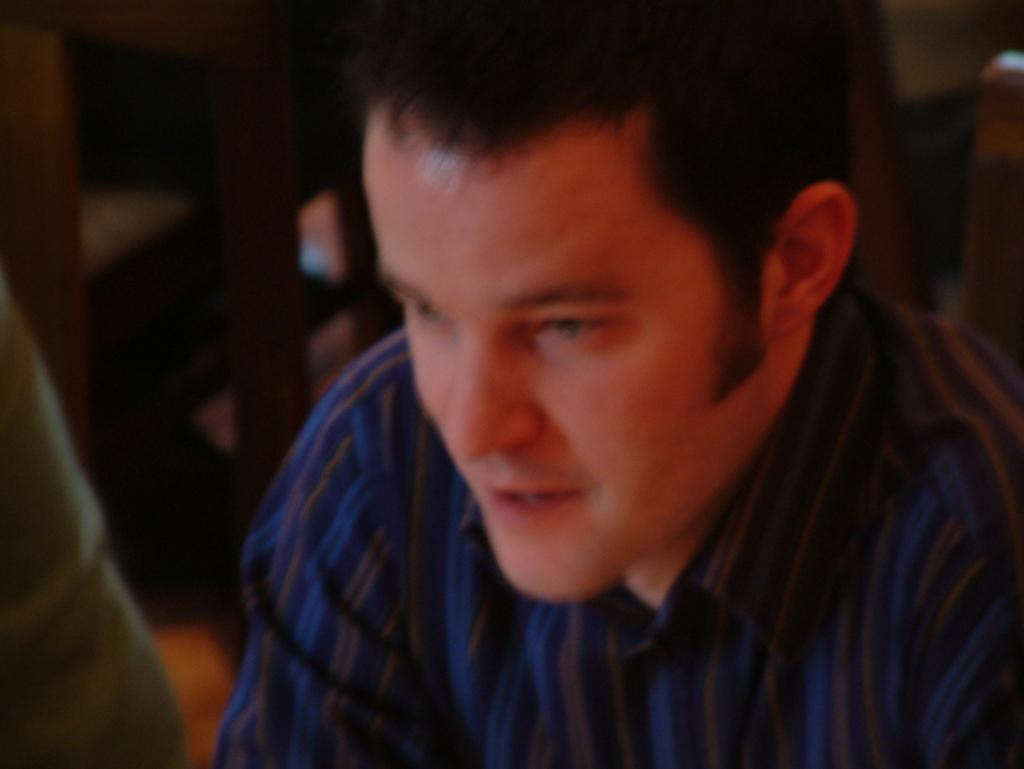Where was the image taken? The image was taken inside a room. What is the main subject in the foreground of the image? There is a man in the foreground of the image. What is the man wearing in the image? The man is wearing a shirt. What else can be seen in the image besides the man? There are other items visible in the background of the image. How many cakes are on the station in the image? There are no cakes or stations present in the image. What type of machine can be seen in the background of the image? There is no machine visible in the background of the image. 